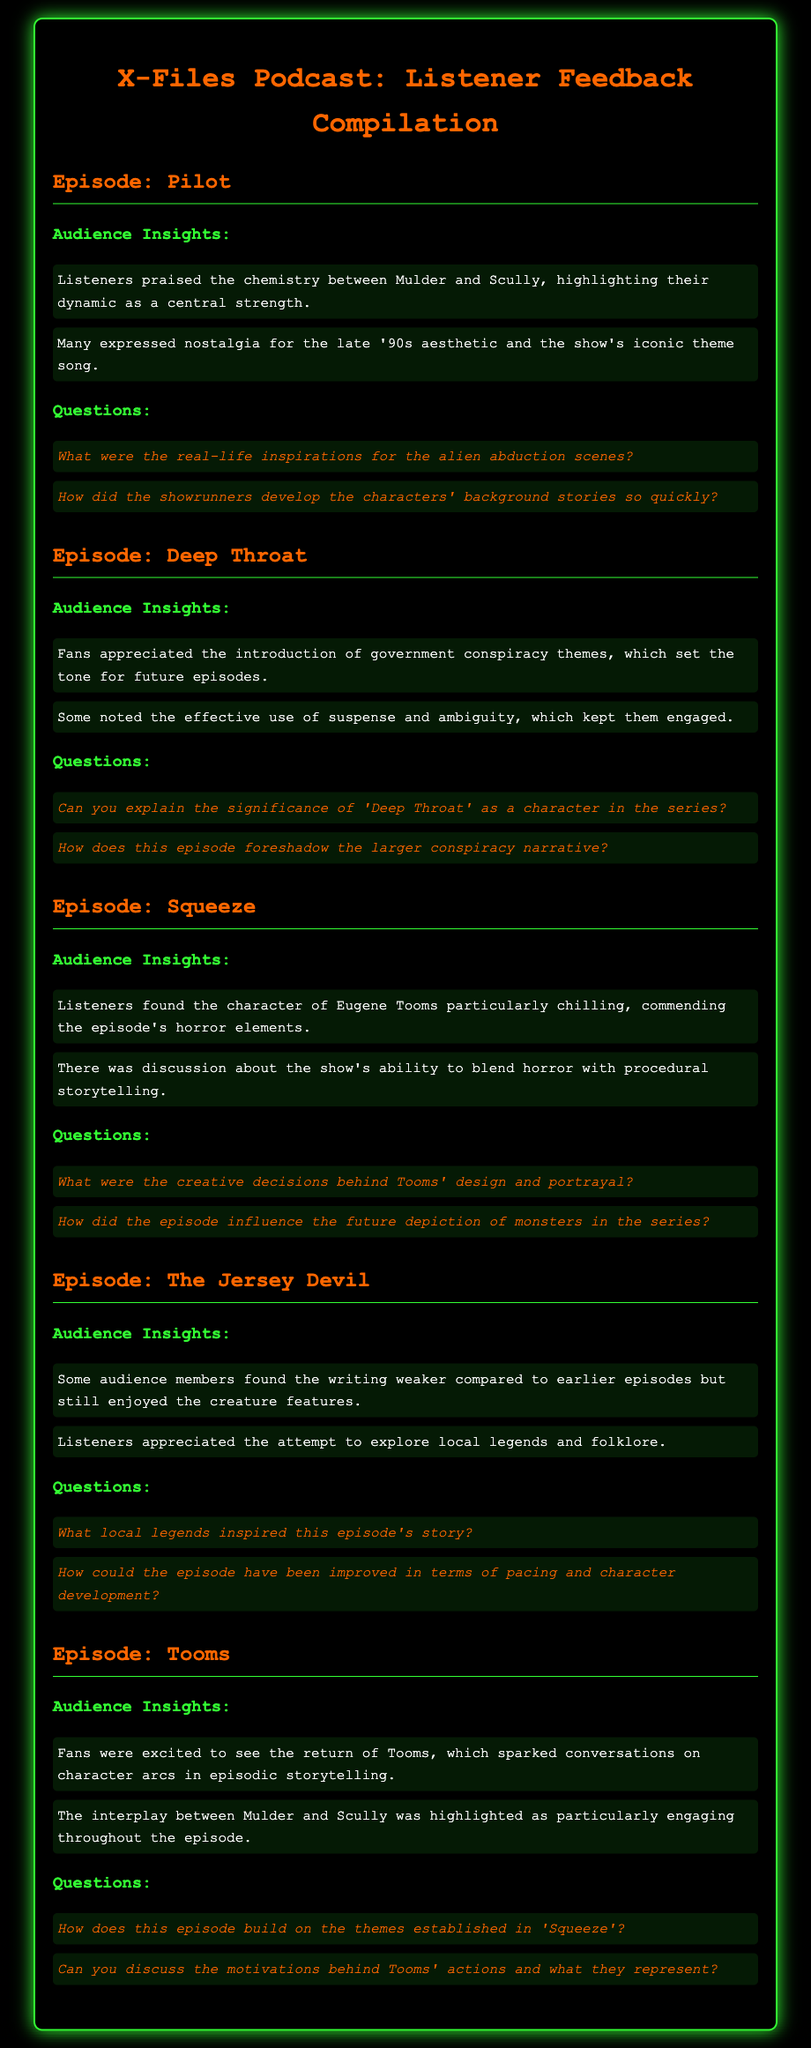what is the title of the podcast? The title of the podcast is clearly stated at the top of the document.
Answer: X-Files Podcast: Listener Feedback Compilation how many insights are listed for the episode "Deep Throat"? The number of insights is found by counting the points listed under the audience insights section for the episode "Deep Throat."
Answer: 2 who is the central character emphasized in the episode "Pilot"? The central characters are mentioned in the audience insights for the episode "Pilot" as being praised for their chemistry.
Answer: Mulder and Scully what episode features the character Eugene Tooms? The episode name is found by looking under the audience insights where Eugene Tooms is mentioned.
Answer: Squeeze which episode discusses local legends and folklore? The answer can be found by looking at the audience insights listing for exploration of folklore.
Answer: The Jersey Devil how many questions are posed for the episode "Tooms"? The number of questions can be determined by counting the questions under the 'Questions' section for the episode "Tooms."
Answer: 2 what color is the text for audience insights? This detail is stated in the styles for the text of specific sections of the document.
Answer: white which character is described as "particularly chilling" in audience insights? The character description can be found in the insights of the episode "Squeeze."
Answer: Eugene Tooms 